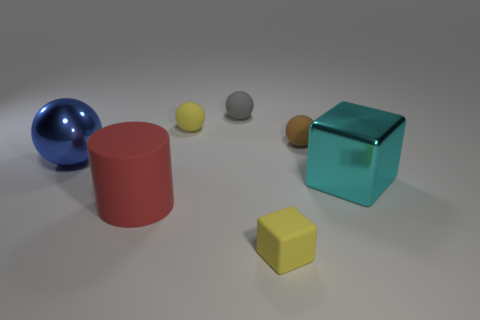There is a shiny cube; does it have the same size as the yellow rubber thing behind the brown object?
Your response must be concise. No. What number of other things are there of the same color as the tiny rubber block?
Provide a short and direct response. 1. Is the number of large matte cylinders that are right of the large cyan block greater than the number of green rubber cubes?
Your answer should be very brief. No. There is a shiny object behind the thing that is to the right of the tiny ball that is on the right side of the gray sphere; what is its color?
Offer a very short reply. Blue. Is the red cylinder made of the same material as the small gray object?
Your answer should be compact. Yes. Is there a yellow metal cylinder that has the same size as the red matte object?
Your answer should be compact. No. What is the material of the gray object that is the same size as the brown rubber thing?
Provide a succinct answer. Rubber. Is there a blue shiny object of the same shape as the red matte object?
Offer a terse response. No. There is a object that is the same color as the rubber block; what is its material?
Make the answer very short. Rubber. What shape is the yellow thing that is on the left side of the gray object?
Ensure brevity in your answer.  Sphere. 